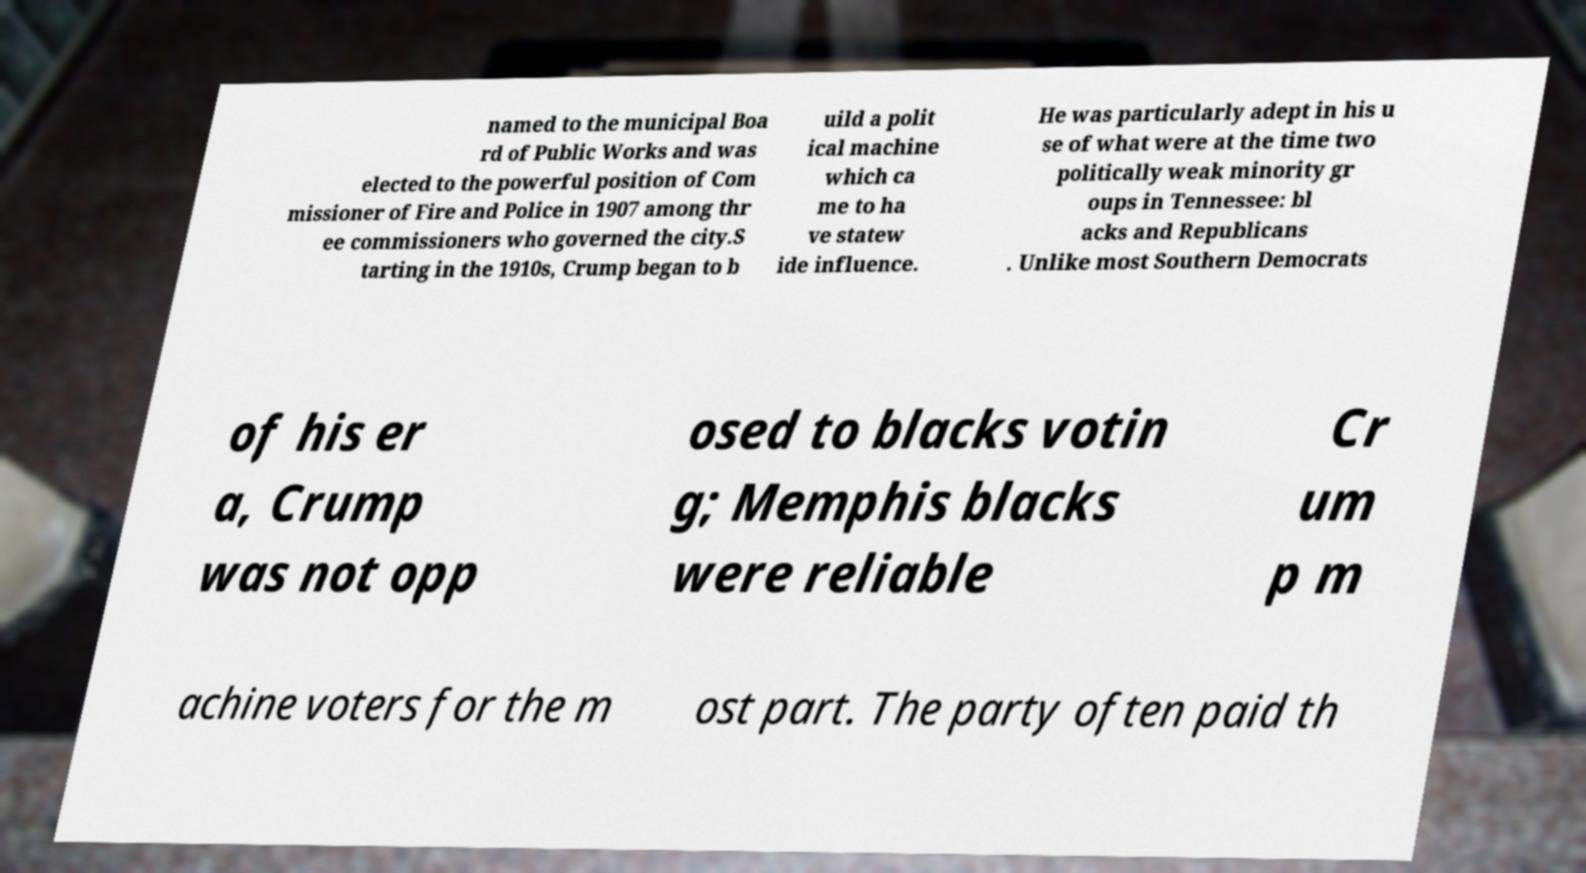Please read and relay the text visible in this image. What does it say? named to the municipal Boa rd of Public Works and was elected to the powerful position of Com missioner of Fire and Police in 1907 among thr ee commissioners who governed the city.S tarting in the 1910s, Crump began to b uild a polit ical machine which ca me to ha ve statew ide influence. He was particularly adept in his u se of what were at the time two politically weak minority gr oups in Tennessee: bl acks and Republicans . Unlike most Southern Democrats of his er a, Crump was not opp osed to blacks votin g; Memphis blacks were reliable Cr um p m achine voters for the m ost part. The party often paid th 